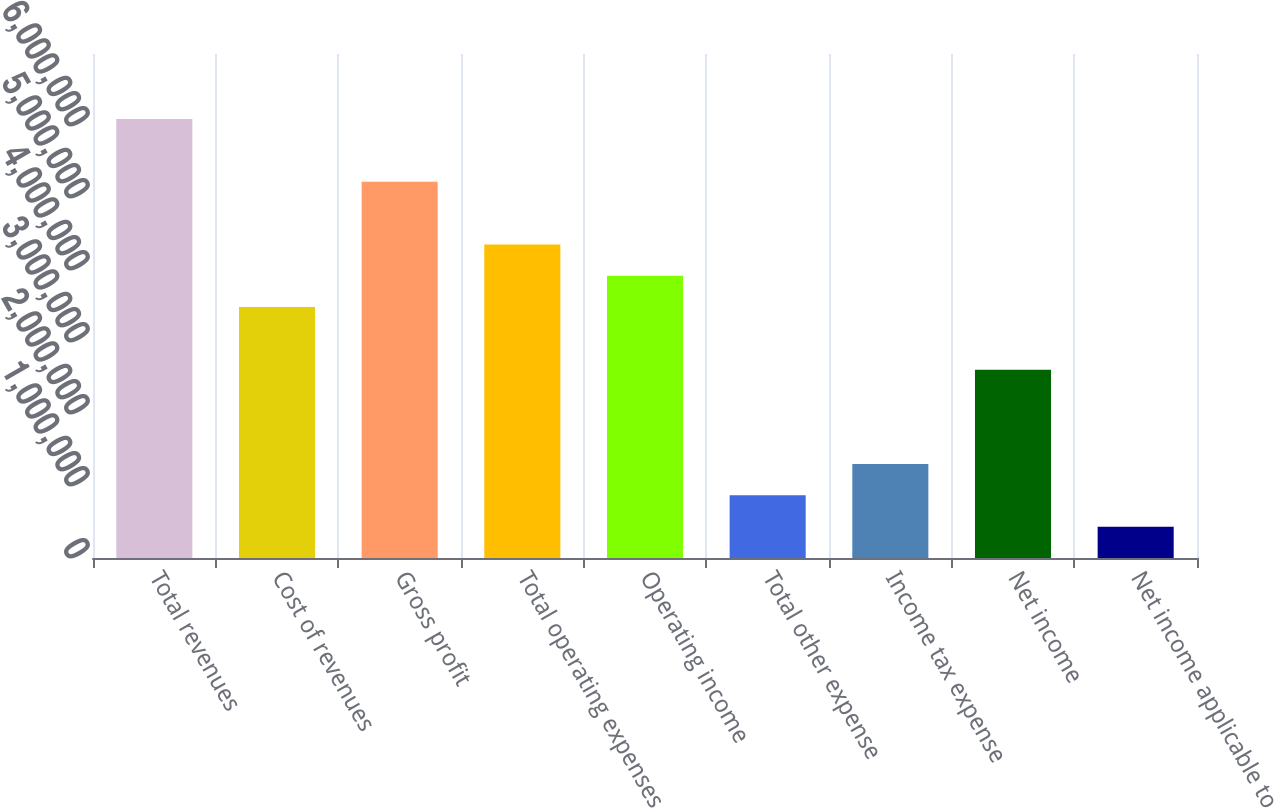Convert chart to OTSL. <chart><loc_0><loc_0><loc_500><loc_500><bar_chart><fcel>Total revenues<fcel>Cost of revenues<fcel>Gross profit<fcel>Total operating expenses<fcel>Operating income<fcel>Total other expense<fcel>Income tax expense<fcel>Net income<fcel>Net income applicable to<nl><fcel>6.09785e+06<fcel>3.48449e+06<fcel>5.22673e+06<fcel>4.35561e+06<fcel>3.92005e+06<fcel>871139<fcel>1.3067e+06<fcel>2.61337e+06<fcel>435580<nl></chart> 